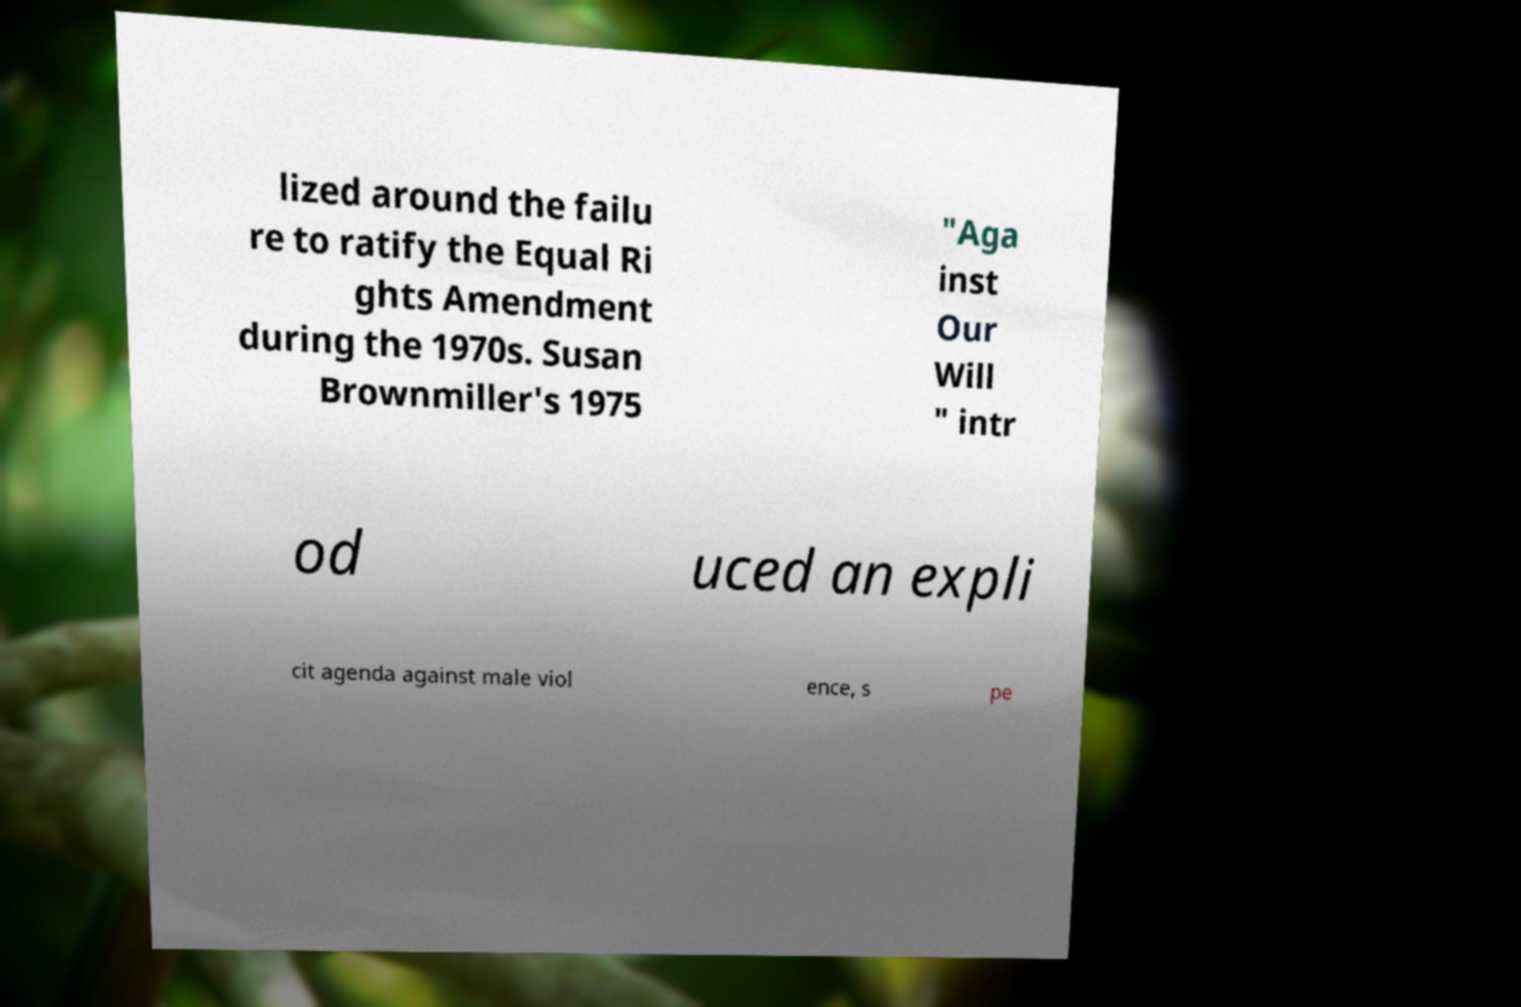Can you accurately transcribe the text from the provided image for me? lized around the failu re to ratify the Equal Ri ghts Amendment during the 1970s. Susan Brownmiller's 1975 "Aga inst Our Will " intr od uced an expli cit agenda against male viol ence, s pe 